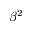Convert formula to latex. <formula><loc_0><loc_0><loc_500><loc_500>\beta ^ { 2 }</formula> 